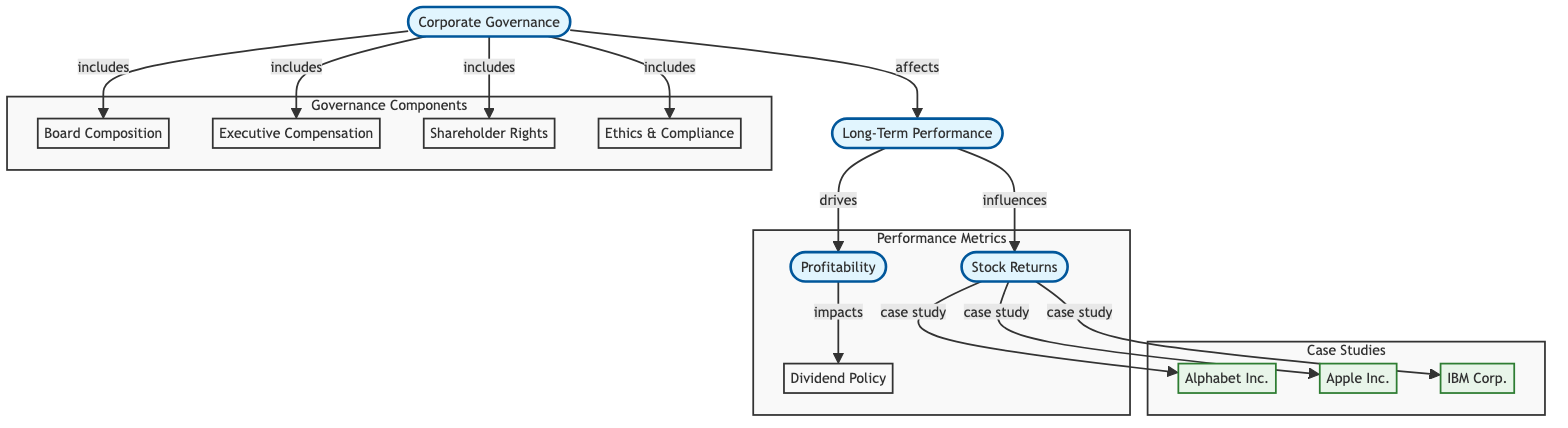What are the components of corporate governance? The diagram explicitly lists four components under "Corporate Governance": Board Composition, Executive Compensation, Shareholder Rights, and Ethics & Compliance.
Answer: Board Composition, Executive Compensation, Shareholder Rights, Ethics & Compliance How many case studies are mentioned in the diagram? The diagram lists three companies as case studies under "Stock Returns": Alphabet Inc., Apple Inc., and IBM Corp. Thus, there are three case studies mentioned.
Answer: 3 Which component drives long-term performance? Long-term performance in the diagram is directly affected by corporate governance, indicating that it is the influence of corporate governance that drives long-term performance.
Answer: Corporate Governance What does long-term performance influence? According to the diagram, long-term performance influences stock returns, meaning that changes in long-term performance will affect how much the stock returns for shareholders.
Answer: Stock Returns What impacts dividend policy in this diagram? The diagram shows that profitability impacts dividend policy, showcasing a flow from profitability to dividend policy, indicating that the company's profits will affect its decisions regarding dividends.
Answer: Profitability Which aspect has the most significant influence on stock returns? The flow in the diagram indicates that long-term performance influences stock returns, thus analyzing stock returns primarily involves understanding long-term performance.
Answer: Long-Term Performance What are the four performance metrics cited in the diagram? The performance metrics listed under "Performance Metrics" in the diagram are profitability, stock returns, and dividend policy; however, there are only three metrics shown explicitly.
Answer: Profitability, Stock Returns, Dividend Policy What dual purpose does corporate governance serve in relation to long-term performance? Corporate governance serves as a foundational component, which not only includes multiple metrics but also affects long-term performance, driving profitability and influencing stock returns as well.
Answer: Affects long-term performance and includes governance metrics 